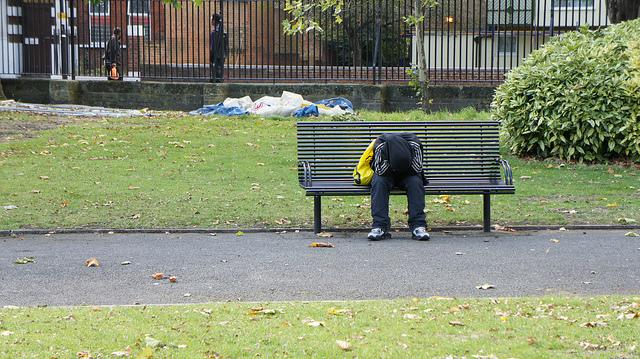Where were the first free public benches invented?

Choices:
A) spain
B) morocco
C) america
D) france france 